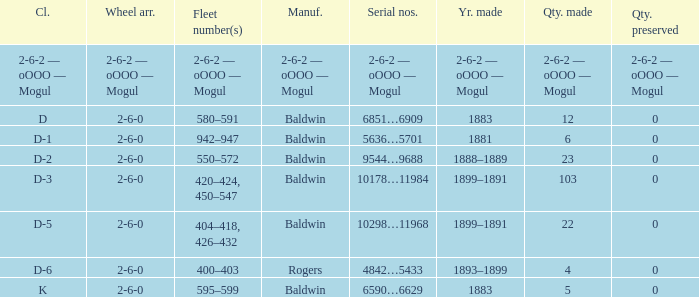What is the class when the quantity perserved is 0 and the quantity made is 5? K. 